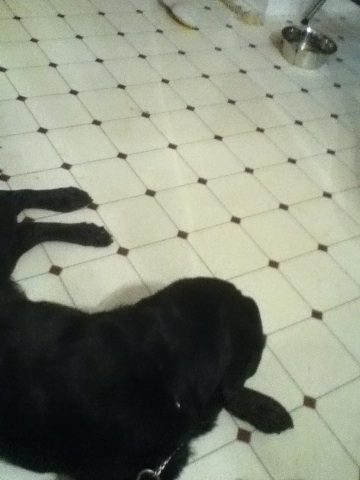What's the environment like in the image? The image shows a tiled floor, likely in a kitchen or a similar room. It seems clean and has a typical home environment with a pet food bowl indicating this is a pet-friendly space. Why do you think only one dog is lying down? The black dog might be lying down because it is tired, taking a rest, or simply relaxed. The other dog might be more alert and active, or perhaps it is about to eat or drink. Do dogs communicate with each other? If yes, how? Yes, dogs communicate with each other through a variety of means including body language, vocalizations like barking and whining, and through their sense of smell. They often use their tails, ears, and overall body posture to convey their feelings and intentions to other dogs. Imagine a wild scenario where these dogs are superheroes. What would their superpowers be? In a wild, imaginative scenario, the black dog could have the superpower of super speed, allowing it to dash around and catch anything in a blink. The other dog could have the ability to communicate telepathically, making it the strategist of the team, coordinating actions and gathering intelligence. Describe a realistic scenario where the dogs are involved in a family activity. A realistic scenario could involve the dogs engaging in a fun game of fetch with the family in the backyard. The children are throwing a ball while the dogs happily chase and retrieve it, bringing it back with wagging tails. The parents watch and laugh, enjoying the playful interaction. What's a simple everyday routine that these dogs might have? On an average day, the dogs might wake up in the morning, go for a walk with their owner, have breakfast, spend some time playing with toys or each other, take an afternoon nap, go for another walk in the evening, have dinner, and then relax with the family before bedtime. 